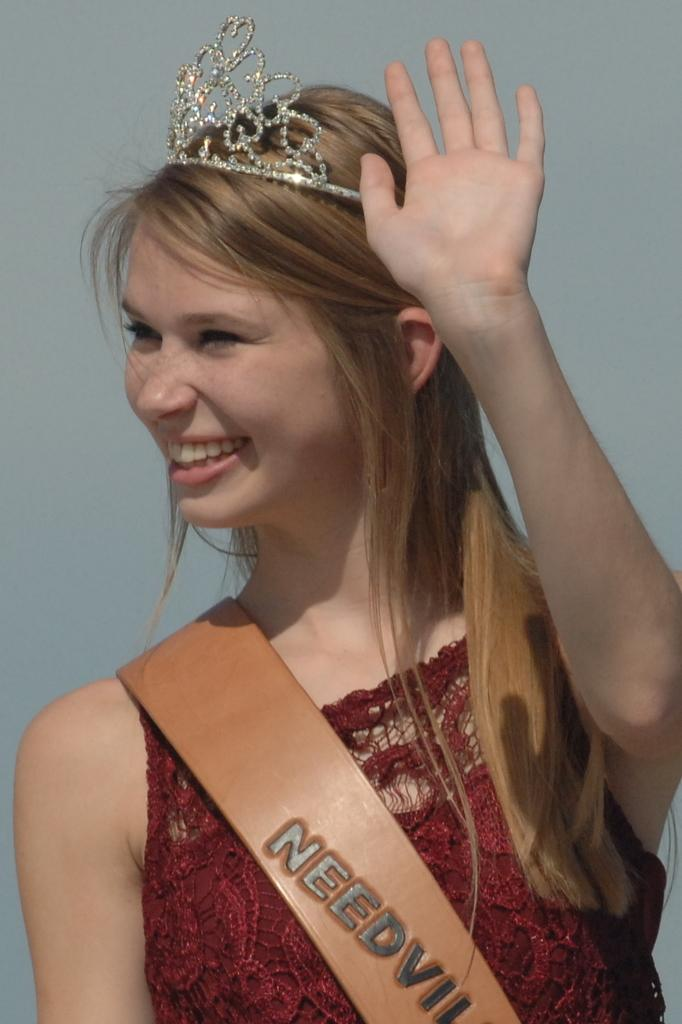Who is present in the image? There is a woman in the image. What is the woman wearing on her head? The woman is wearing a crown. What else is the woman wearing? The woman is wearing a sash. What expression does the woman have? The woman is smiling. What type of army is the woman leading in the image? There is no army present in the image; it features a woman wearing a crown and a sash. How many cattle can be seen grazing in the background of the image? There are no cattle present in the image. 